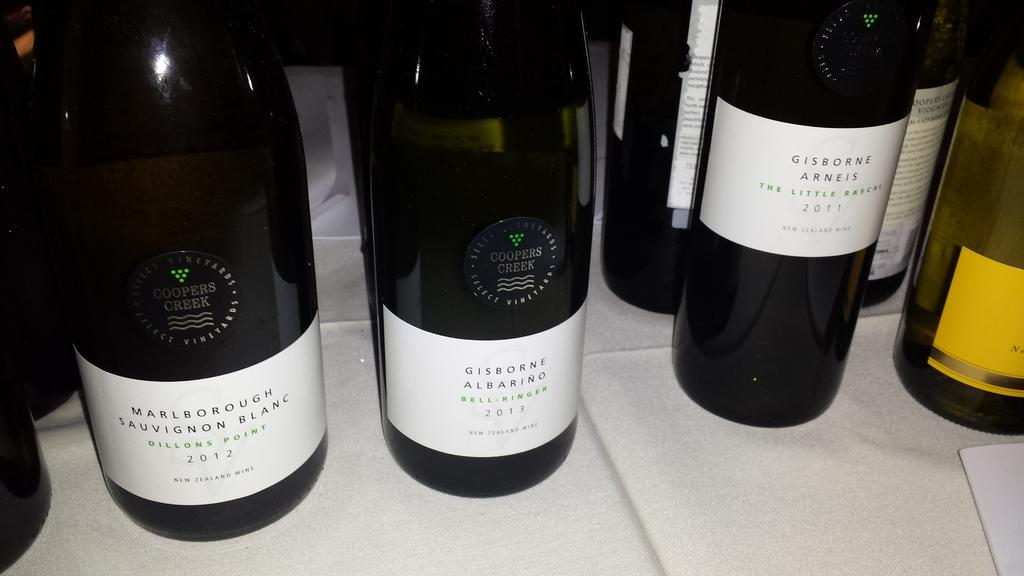What type of beverage bottles are present in the image? There are wine bottles in the image. What is the color of the wine bottles? The wine bottles are black in color. Can you tell me how the guide is dressed in the image? There is no guide present in the image; it only features black wine bottles. What type of clothing is the vest being worn by in the image? There is no person wearing a vest in the image. 